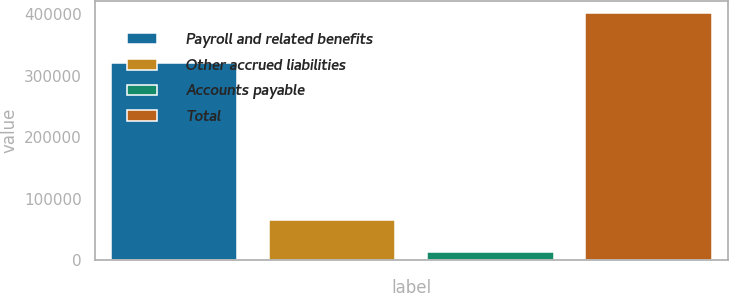Convert chart to OTSL. <chart><loc_0><loc_0><loc_500><loc_500><bar_chart><fcel>Payroll and related benefits<fcel>Other accrued liabilities<fcel>Accounts payable<fcel>Total<nl><fcel>321430<fcel>66276<fcel>13745<fcel>401451<nl></chart> 